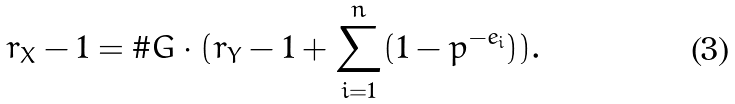Convert formula to latex. <formula><loc_0><loc_0><loc_500><loc_500>r _ { X } - 1 = \# G \cdot ( r _ { Y } - 1 + \sum _ { i = 1 } ^ { n } ( 1 - p ^ { - e _ { i } } ) ) .</formula> 